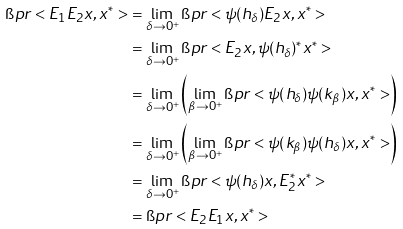Convert formula to latex. <formula><loc_0><loc_0><loc_500><loc_500>\i p r < E _ { 1 } E _ { 2 } x , x ^ { * } > & = \lim _ { \delta \to 0 ^ { + } } \i p r < \psi ( h _ { \delta } ) E _ { 2 } x , x ^ { * } > \\ & = \lim _ { \delta \to 0 ^ { + } } \i p r < E _ { 2 } x , \psi ( h _ { \delta } ) ^ { * } x ^ { * } > \\ & = \lim _ { \delta \to 0 ^ { + } } \left ( \lim _ { \beta \to 0 ^ { + } } \i p r < \psi ( h _ { \delta } ) \psi ( k _ { \beta } ) x , x ^ { * } > \right ) \\ & = \lim _ { \delta \to 0 ^ { + } } \left ( \lim _ { \beta \to 0 ^ { + } } \i p r < \psi ( k _ { \beta } ) \psi ( h _ { \delta } ) x , x ^ { * } > \right ) \\ & = \lim _ { \delta \to 0 ^ { + } } \i p r < \psi ( h _ { \delta } ) x , E _ { 2 } ^ { * } x ^ { * } > \\ & = \i p r < E _ { 2 } E _ { 1 } x , x ^ { * } ></formula> 